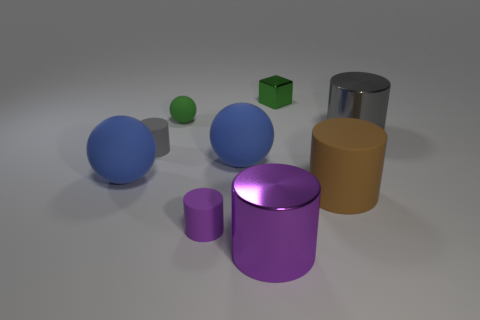Is there a big cube? While there is indeed a cube in the image, it's relatively small in comparison to the other geometric shapes present, such as the large spheres and cylinders. 